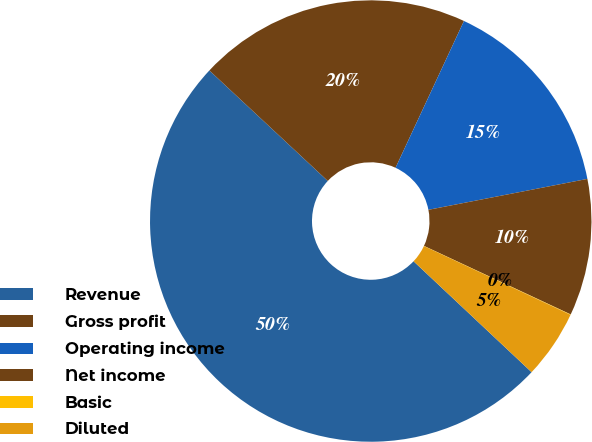Convert chart. <chart><loc_0><loc_0><loc_500><loc_500><pie_chart><fcel>Revenue<fcel>Gross profit<fcel>Operating income<fcel>Net income<fcel>Basic<fcel>Diluted<nl><fcel>49.94%<fcel>19.99%<fcel>15.0%<fcel>10.01%<fcel>0.03%<fcel>5.02%<nl></chart> 